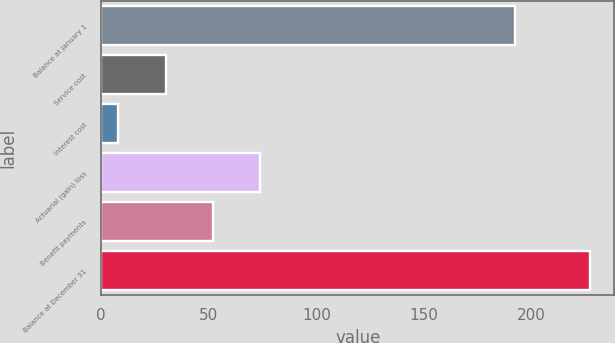Convert chart to OTSL. <chart><loc_0><loc_0><loc_500><loc_500><bar_chart><fcel>Balance at January 1<fcel>Service cost<fcel>Interest cost<fcel>Actuarial (gain) loss<fcel>Benefit payments<fcel>Balance at December 31<nl><fcel>192<fcel>29.9<fcel>8<fcel>73.7<fcel>51.8<fcel>227<nl></chart> 